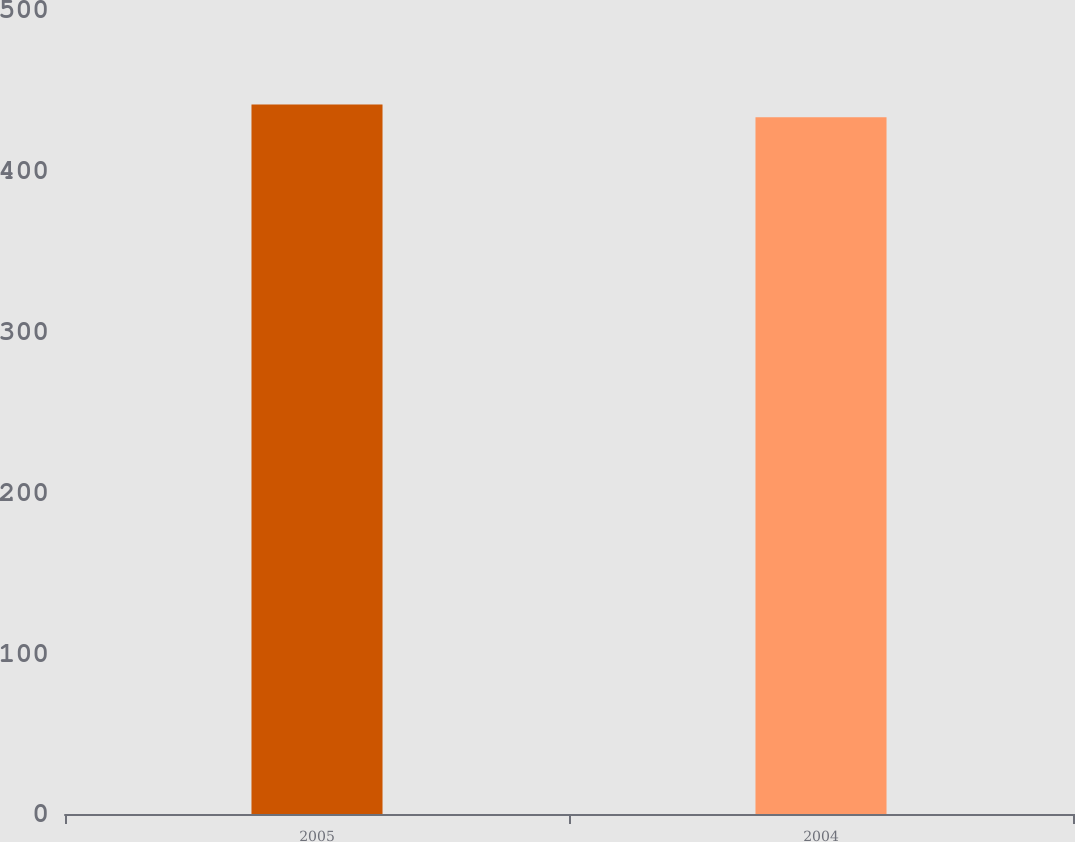Convert chart to OTSL. <chart><loc_0><loc_0><loc_500><loc_500><bar_chart><fcel>2005<fcel>2004<nl><fcel>441.2<fcel>433.3<nl></chart> 